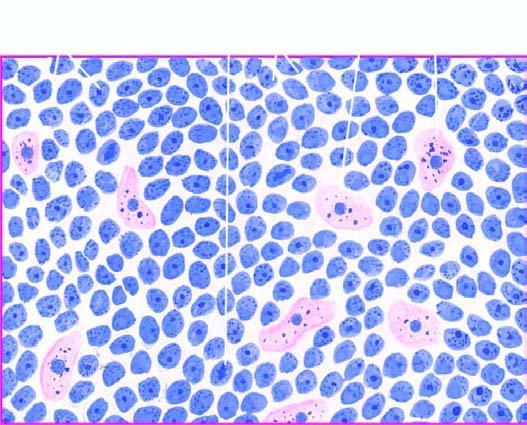what shows uniform cells having high mitotic rate?
Answer the question using a single word or phrase. The tumour 